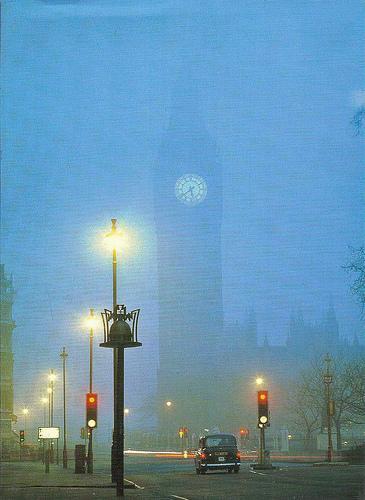How many cars are pictured?
Give a very brief answer. 1. 